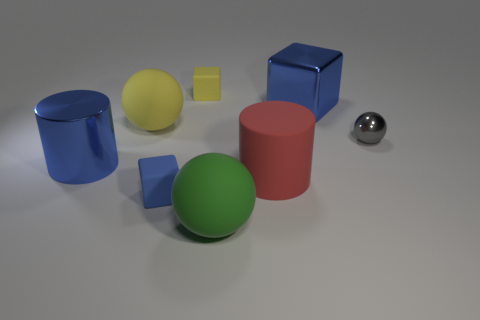Add 2 big purple things. How many objects exist? 10 Subtract all spheres. How many objects are left? 5 Add 4 blue shiny blocks. How many blue shiny blocks are left? 5 Add 4 big spheres. How many big spheres exist? 6 Subtract 0 purple cylinders. How many objects are left? 8 Subtract all big blue rubber blocks. Subtract all matte cylinders. How many objects are left? 7 